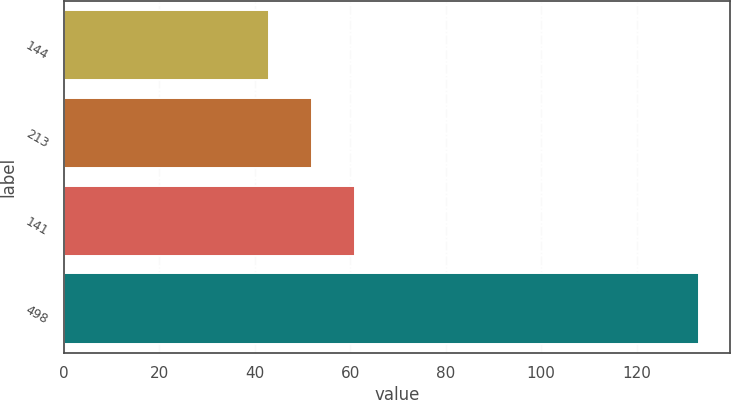Convert chart to OTSL. <chart><loc_0><loc_0><loc_500><loc_500><bar_chart><fcel>144<fcel>213<fcel>141<fcel>498<nl><fcel>43<fcel>52<fcel>61<fcel>133<nl></chart> 